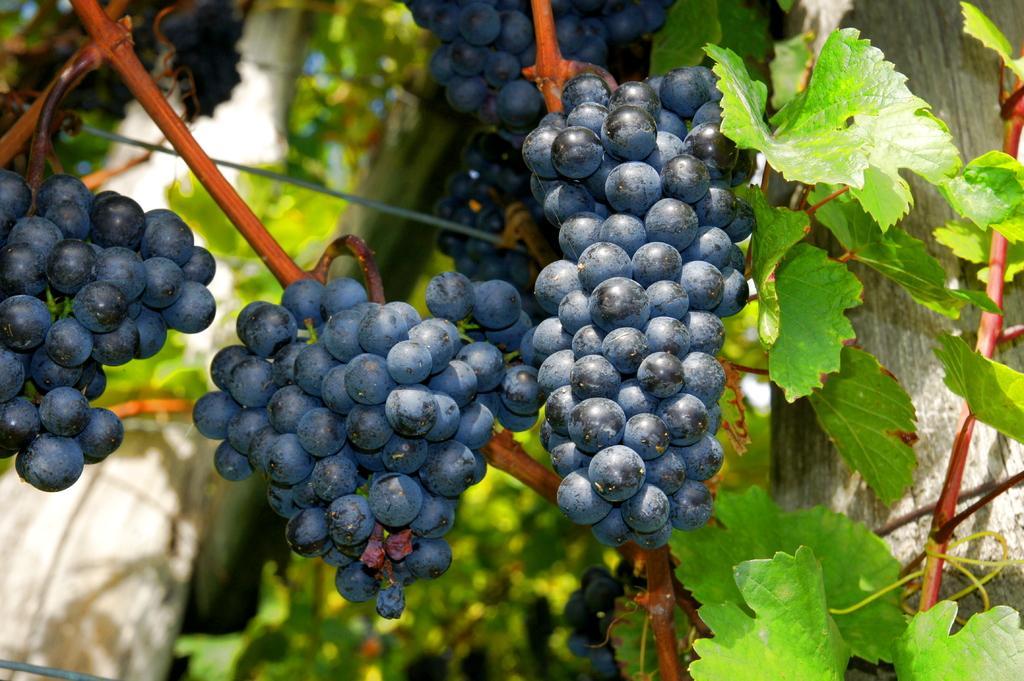In one or two sentences, can you explain what this image depicts? It is a zoomed in picture of the grape tree. 